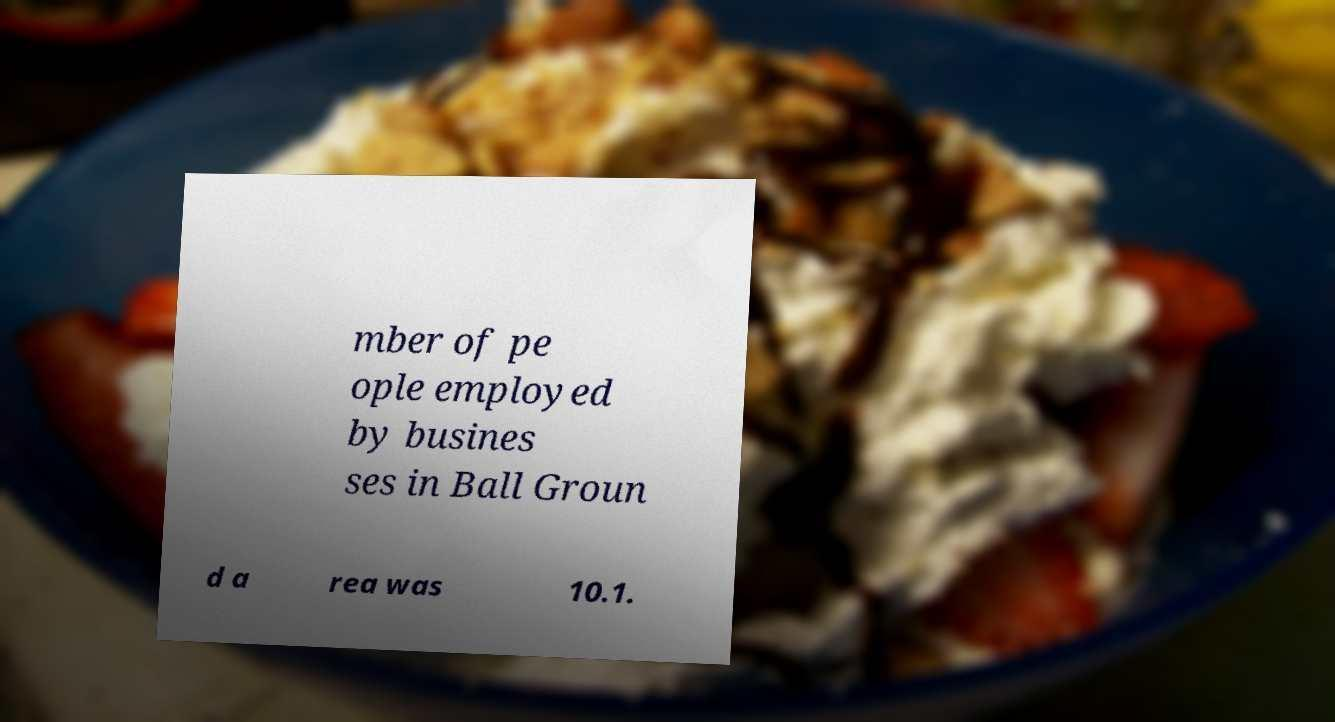What messages or text are displayed in this image? I need them in a readable, typed format. mber of pe ople employed by busines ses in Ball Groun d a rea was 10.1. 